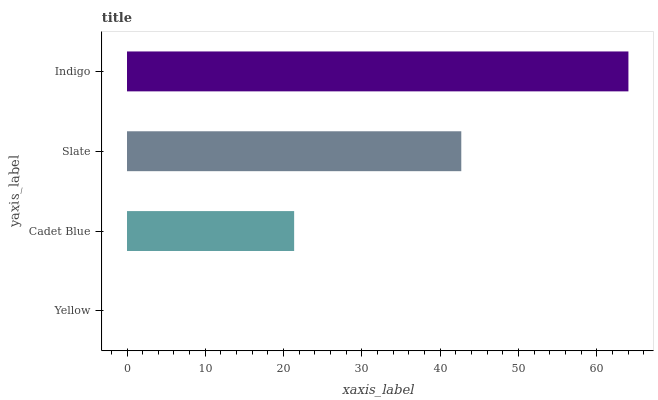Is Yellow the minimum?
Answer yes or no. Yes. Is Indigo the maximum?
Answer yes or no. Yes. Is Cadet Blue the minimum?
Answer yes or no. No. Is Cadet Blue the maximum?
Answer yes or no. No. Is Cadet Blue greater than Yellow?
Answer yes or no. Yes. Is Yellow less than Cadet Blue?
Answer yes or no. Yes. Is Yellow greater than Cadet Blue?
Answer yes or no. No. Is Cadet Blue less than Yellow?
Answer yes or no. No. Is Slate the high median?
Answer yes or no. Yes. Is Cadet Blue the low median?
Answer yes or no. Yes. Is Cadet Blue the high median?
Answer yes or no. No. Is Yellow the low median?
Answer yes or no. No. 